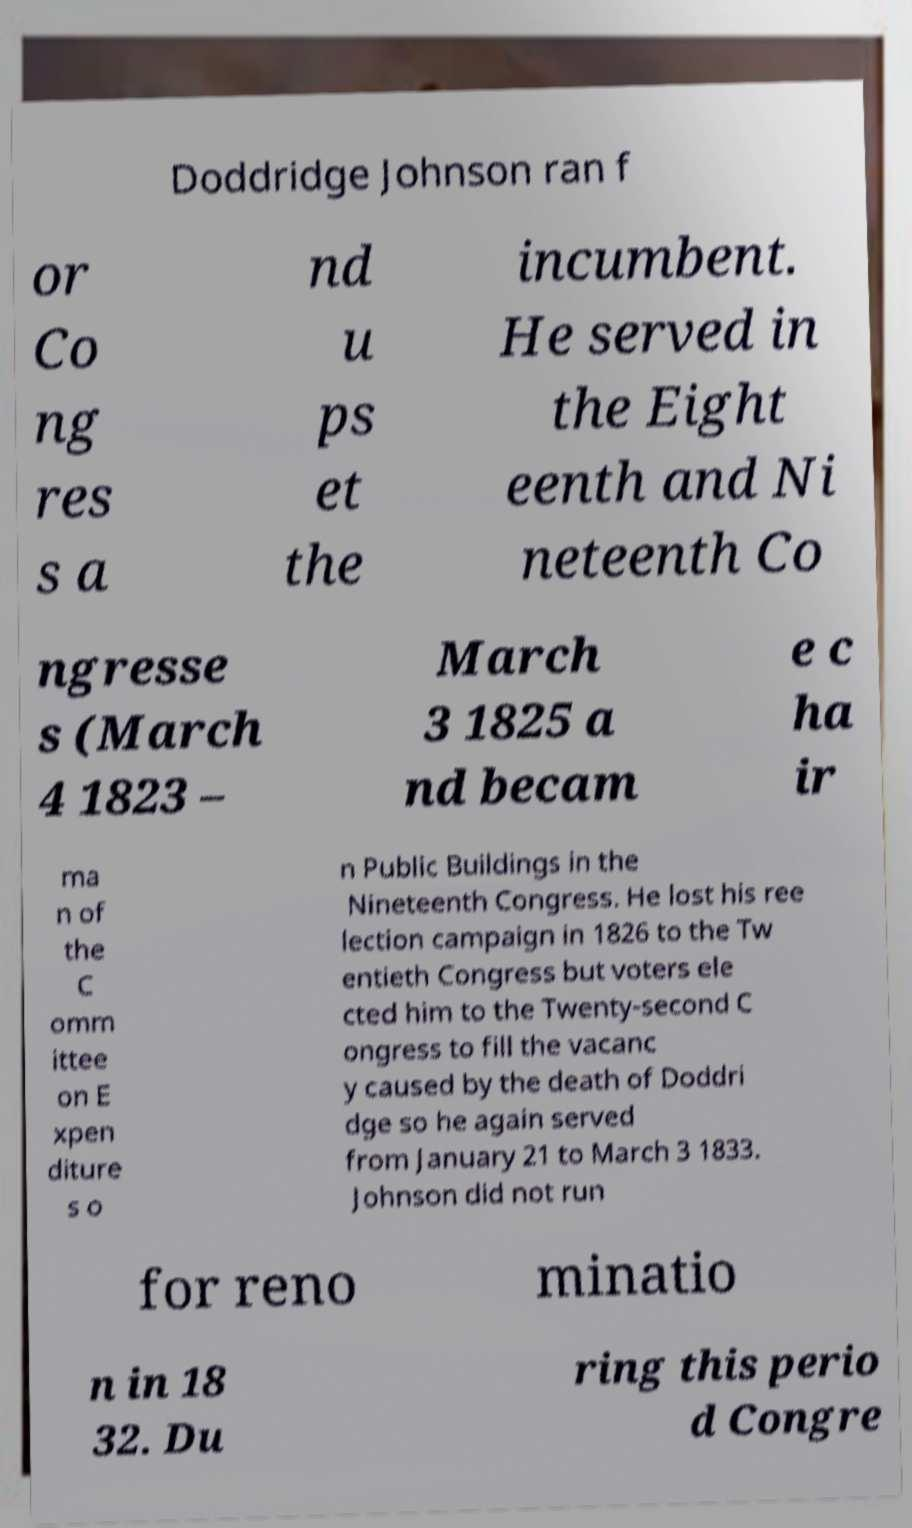I need the written content from this picture converted into text. Can you do that? Doddridge Johnson ran f or Co ng res s a nd u ps et the incumbent. He served in the Eight eenth and Ni neteenth Co ngresse s (March 4 1823 – March 3 1825 a nd becam e c ha ir ma n of the C omm ittee on E xpen diture s o n Public Buildings in the Nineteenth Congress. He lost his ree lection campaign in 1826 to the Tw entieth Congress but voters ele cted him to the Twenty-second C ongress to fill the vacanc y caused by the death of Doddri dge so he again served from January 21 to March 3 1833. Johnson did not run for reno minatio n in 18 32. Du ring this perio d Congre 